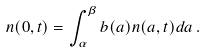<formula> <loc_0><loc_0><loc_500><loc_500>n ( 0 , t ) = \int _ { \alpha } ^ { \beta } b ( a ) n ( a , t ) d a \, .</formula> 